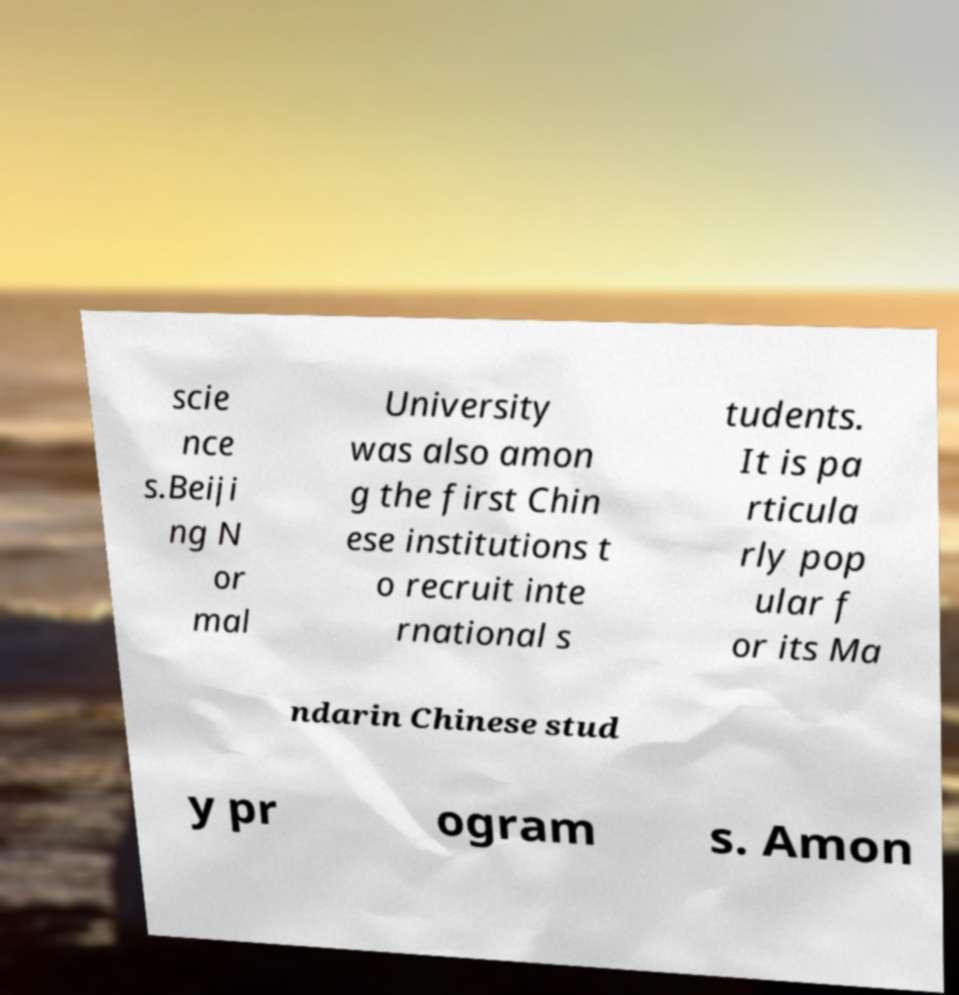Could you assist in decoding the text presented in this image and type it out clearly? scie nce s.Beiji ng N or mal University was also amon g the first Chin ese institutions t o recruit inte rnational s tudents. It is pa rticula rly pop ular f or its Ma ndarin Chinese stud y pr ogram s. Amon 